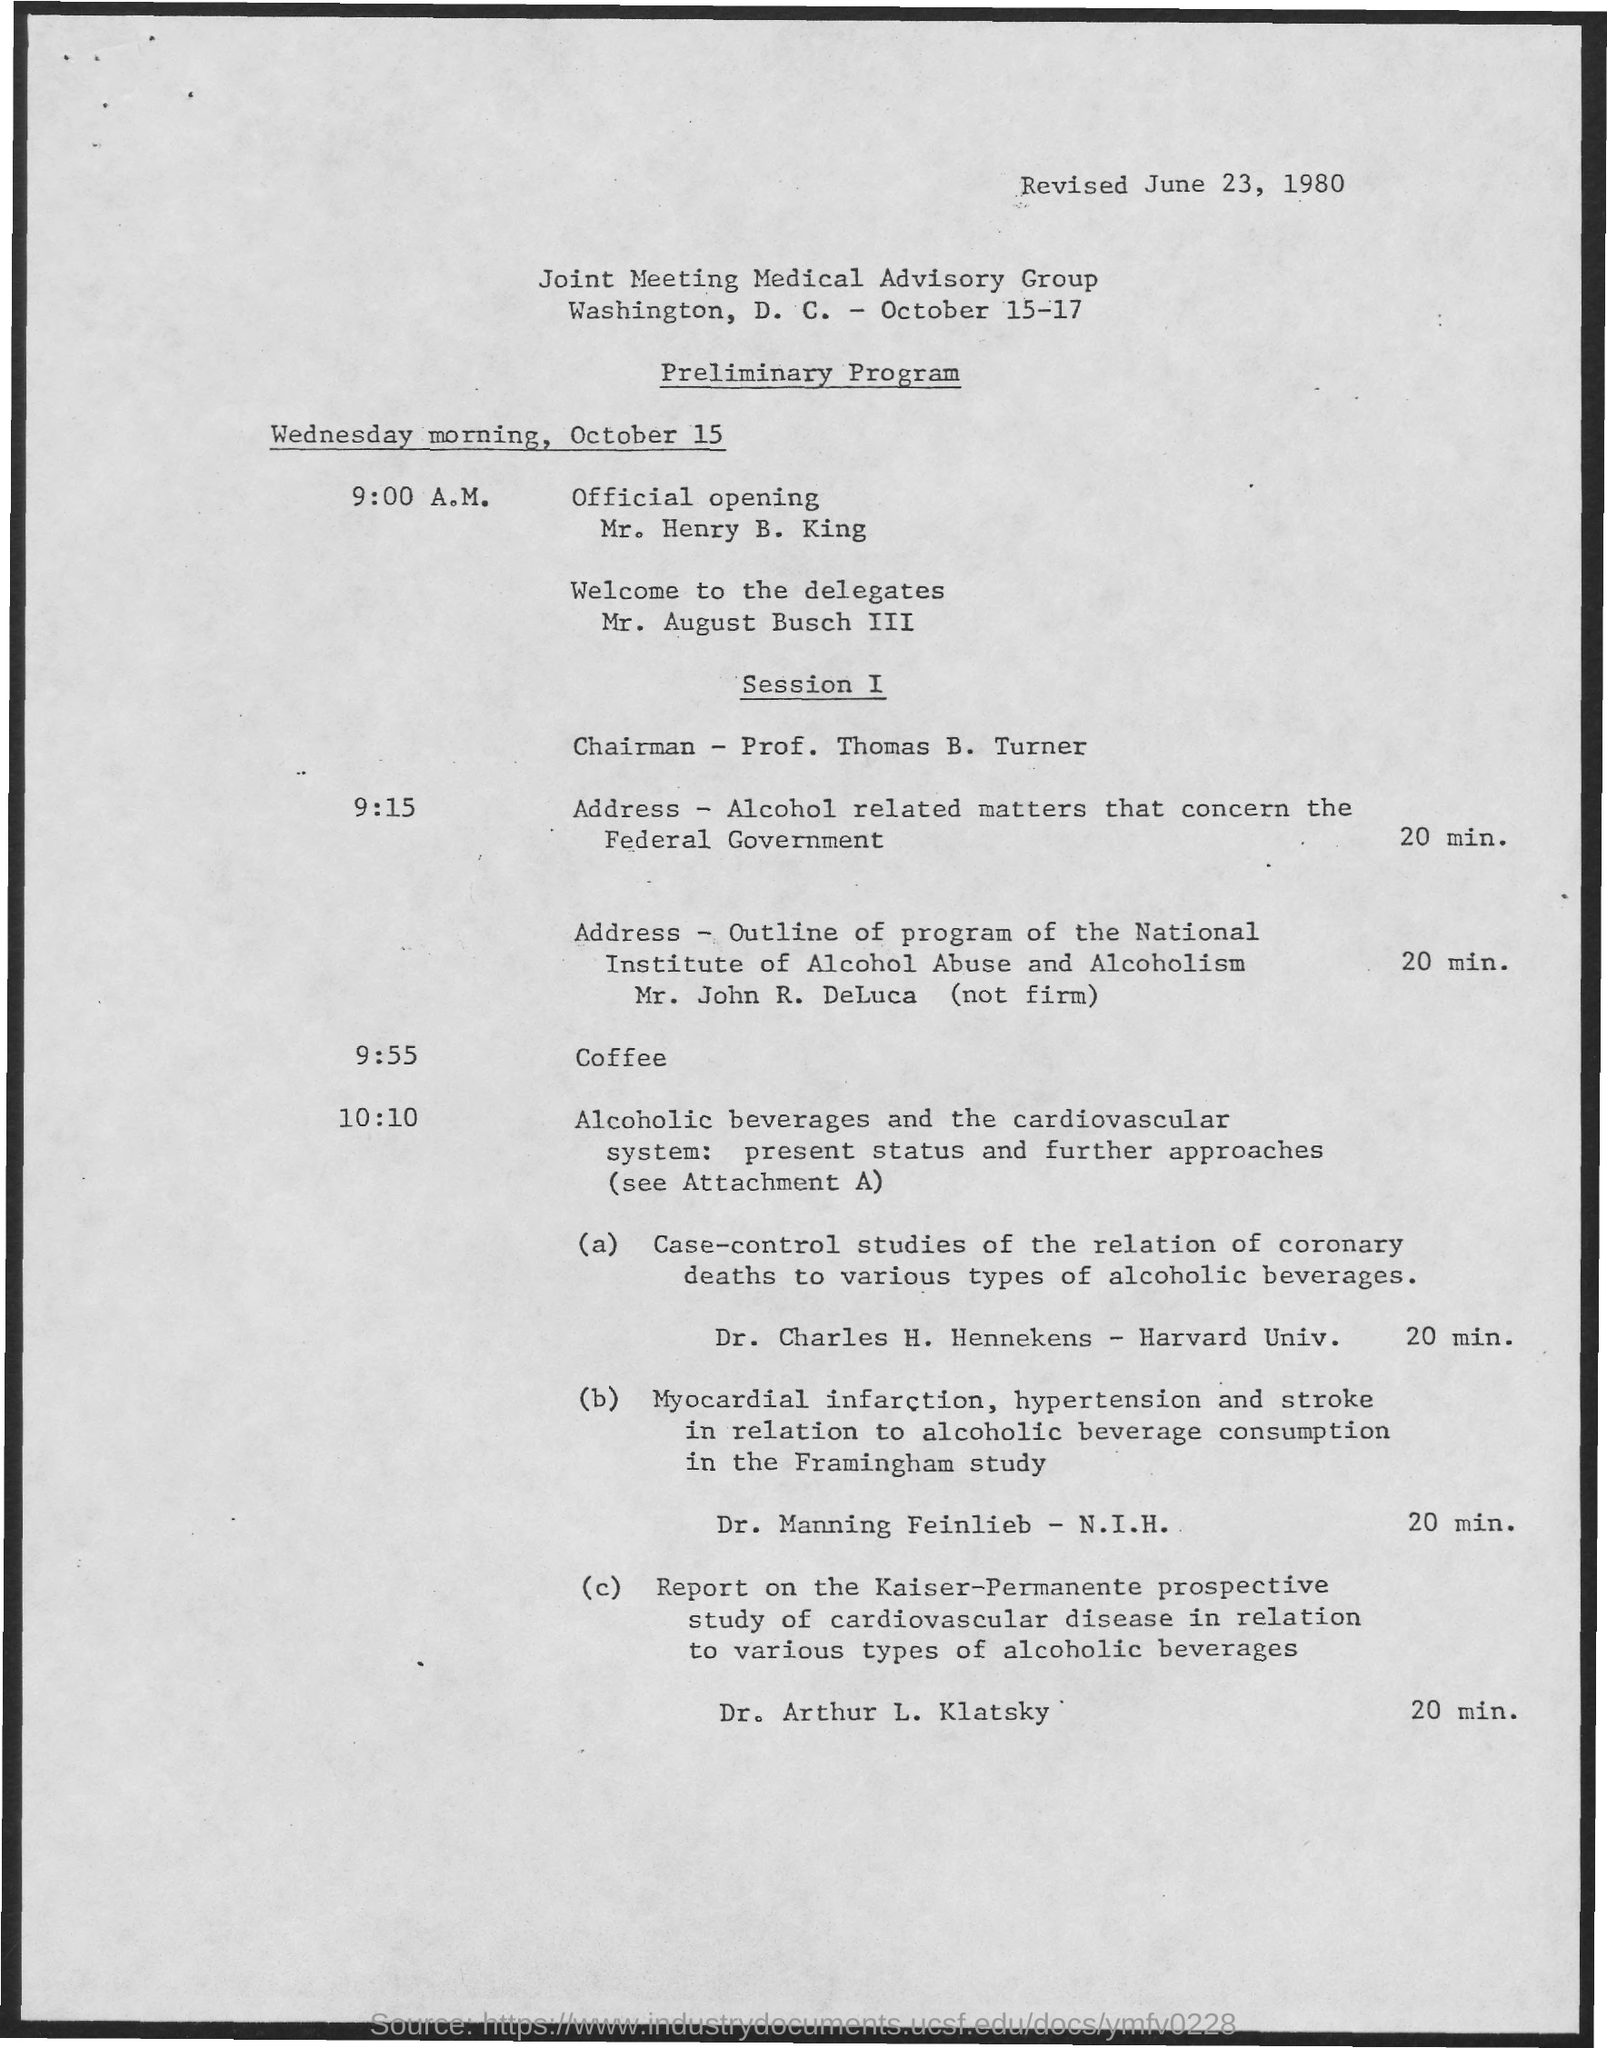What is the Revised date?
Give a very brief answer. June 23, 1980. What is the Coffee Time ?
Offer a very short reply. 9:55. 